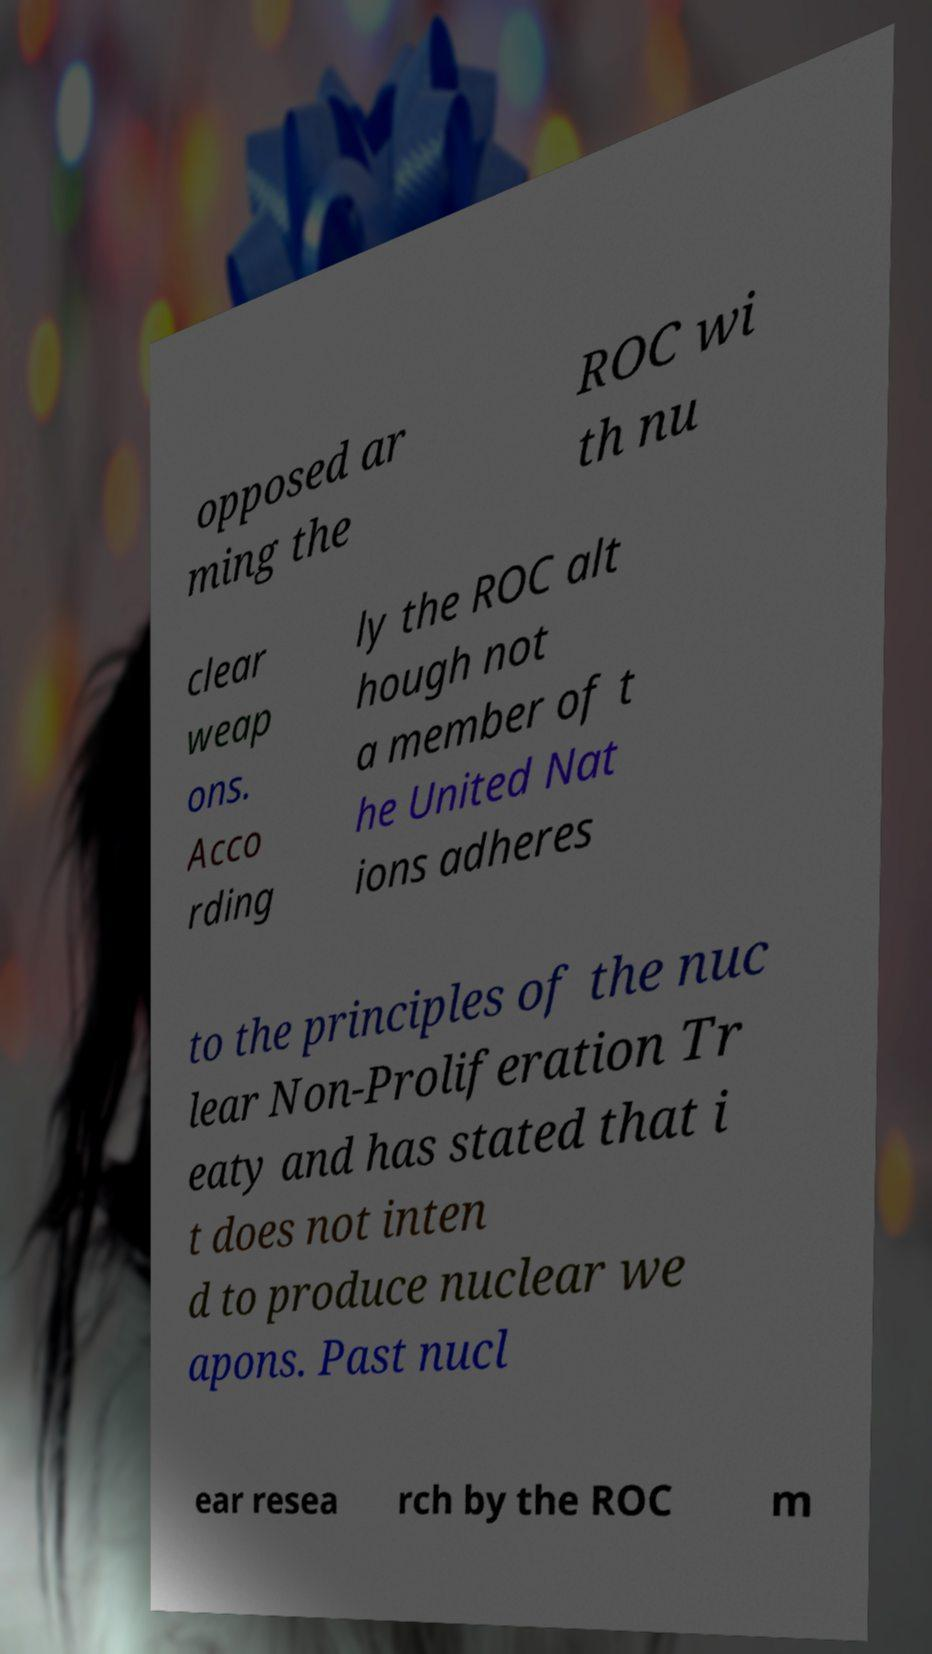There's text embedded in this image that I need extracted. Can you transcribe it verbatim? opposed ar ming the ROC wi th nu clear weap ons. Acco rding ly the ROC alt hough not a member of t he United Nat ions adheres to the principles of the nuc lear Non-Proliferation Tr eaty and has stated that i t does not inten d to produce nuclear we apons. Past nucl ear resea rch by the ROC m 